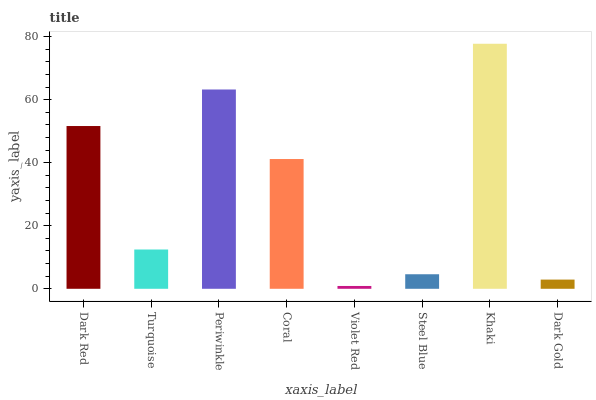Is Turquoise the minimum?
Answer yes or no. No. Is Turquoise the maximum?
Answer yes or no. No. Is Dark Red greater than Turquoise?
Answer yes or no. Yes. Is Turquoise less than Dark Red?
Answer yes or no. Yes. Is Turquoise greater than Dark Red?
Answer yes or no. No. Is Dark Red less than Turquoise?
Answer yes or no. No. Is Coral the high median?
Answer yes or no. Yes. Is Turquoise the low median?
Answer yes or no. Yes. Is Violet Red the high median?
Answer yes or no. No. Is Periwinkle the low median?
Answer yes or no. No. 